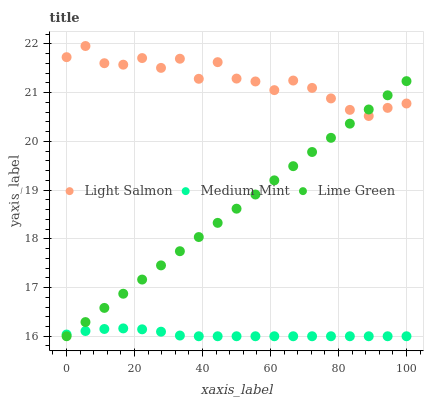Does Medium Mint have the minimum area under the curve?
Answer yes or no. Yes. Does Light Salmon have the maximum area under the curve?
Answer yes or no. Yes. Does Lime Green have the minimum area under the curve?
Answer yes or no. No. Does Lime Green have the maximum area under the curve?
Answer yes or no. No. Is Lime Green the smoothest?
Answer yes or no. Yes. Is Light Salmon the roughest?
Answer yes or no. Yes. Is Light Salmon the smoothest?
Answer yes or no. No. Is Lime Green the roughest?
Answer yes or no. No. Does Medium Mint have the lowest value?
Answer yes or no. Yes. Does Light Salmon have the lowest value?
Answer yes or no. No. Does Light Salmon have the highest value?
Answer yes or no. Yes. Does Lime Green have the highest value?
Answer yes or no. No. Is Medium Mint less than Light Salmon?
Answer yes or no. Yes. Is Light Salmon greater than Medium Mint?
Answer yes or no. Yes. Does Light Salmon intersect Lime Green?
Answer yes or no. Yes. Is Light Salmon less than Lime Green?
Answer yes or no. No. Is Light Salmon greater than Lime Green?
Answer yes or no. No. Does Medium Mint intersect Light Salmon?
Answer yes or no. No. 